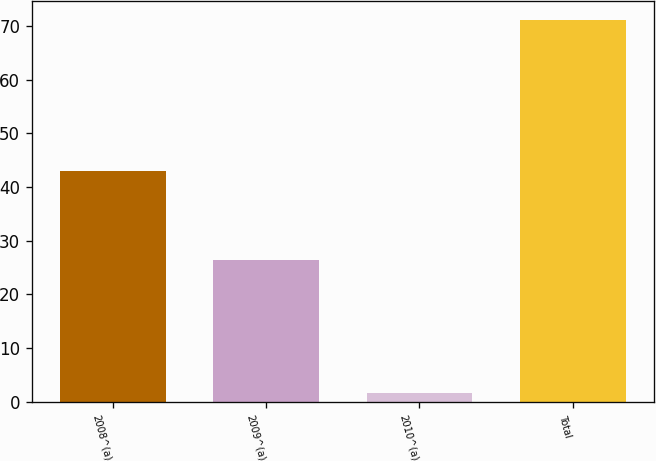<chart> <loc_0><loc_0><loc_500><loc_500><bar_chart><fcel>2008^(a)<fcel>2009^(a)<fcel>2010^(a)<fcel>Total<nl><fcel>42.9<fcel>26.5<fcel>1.7<fcel>71.1<nl></chart> 